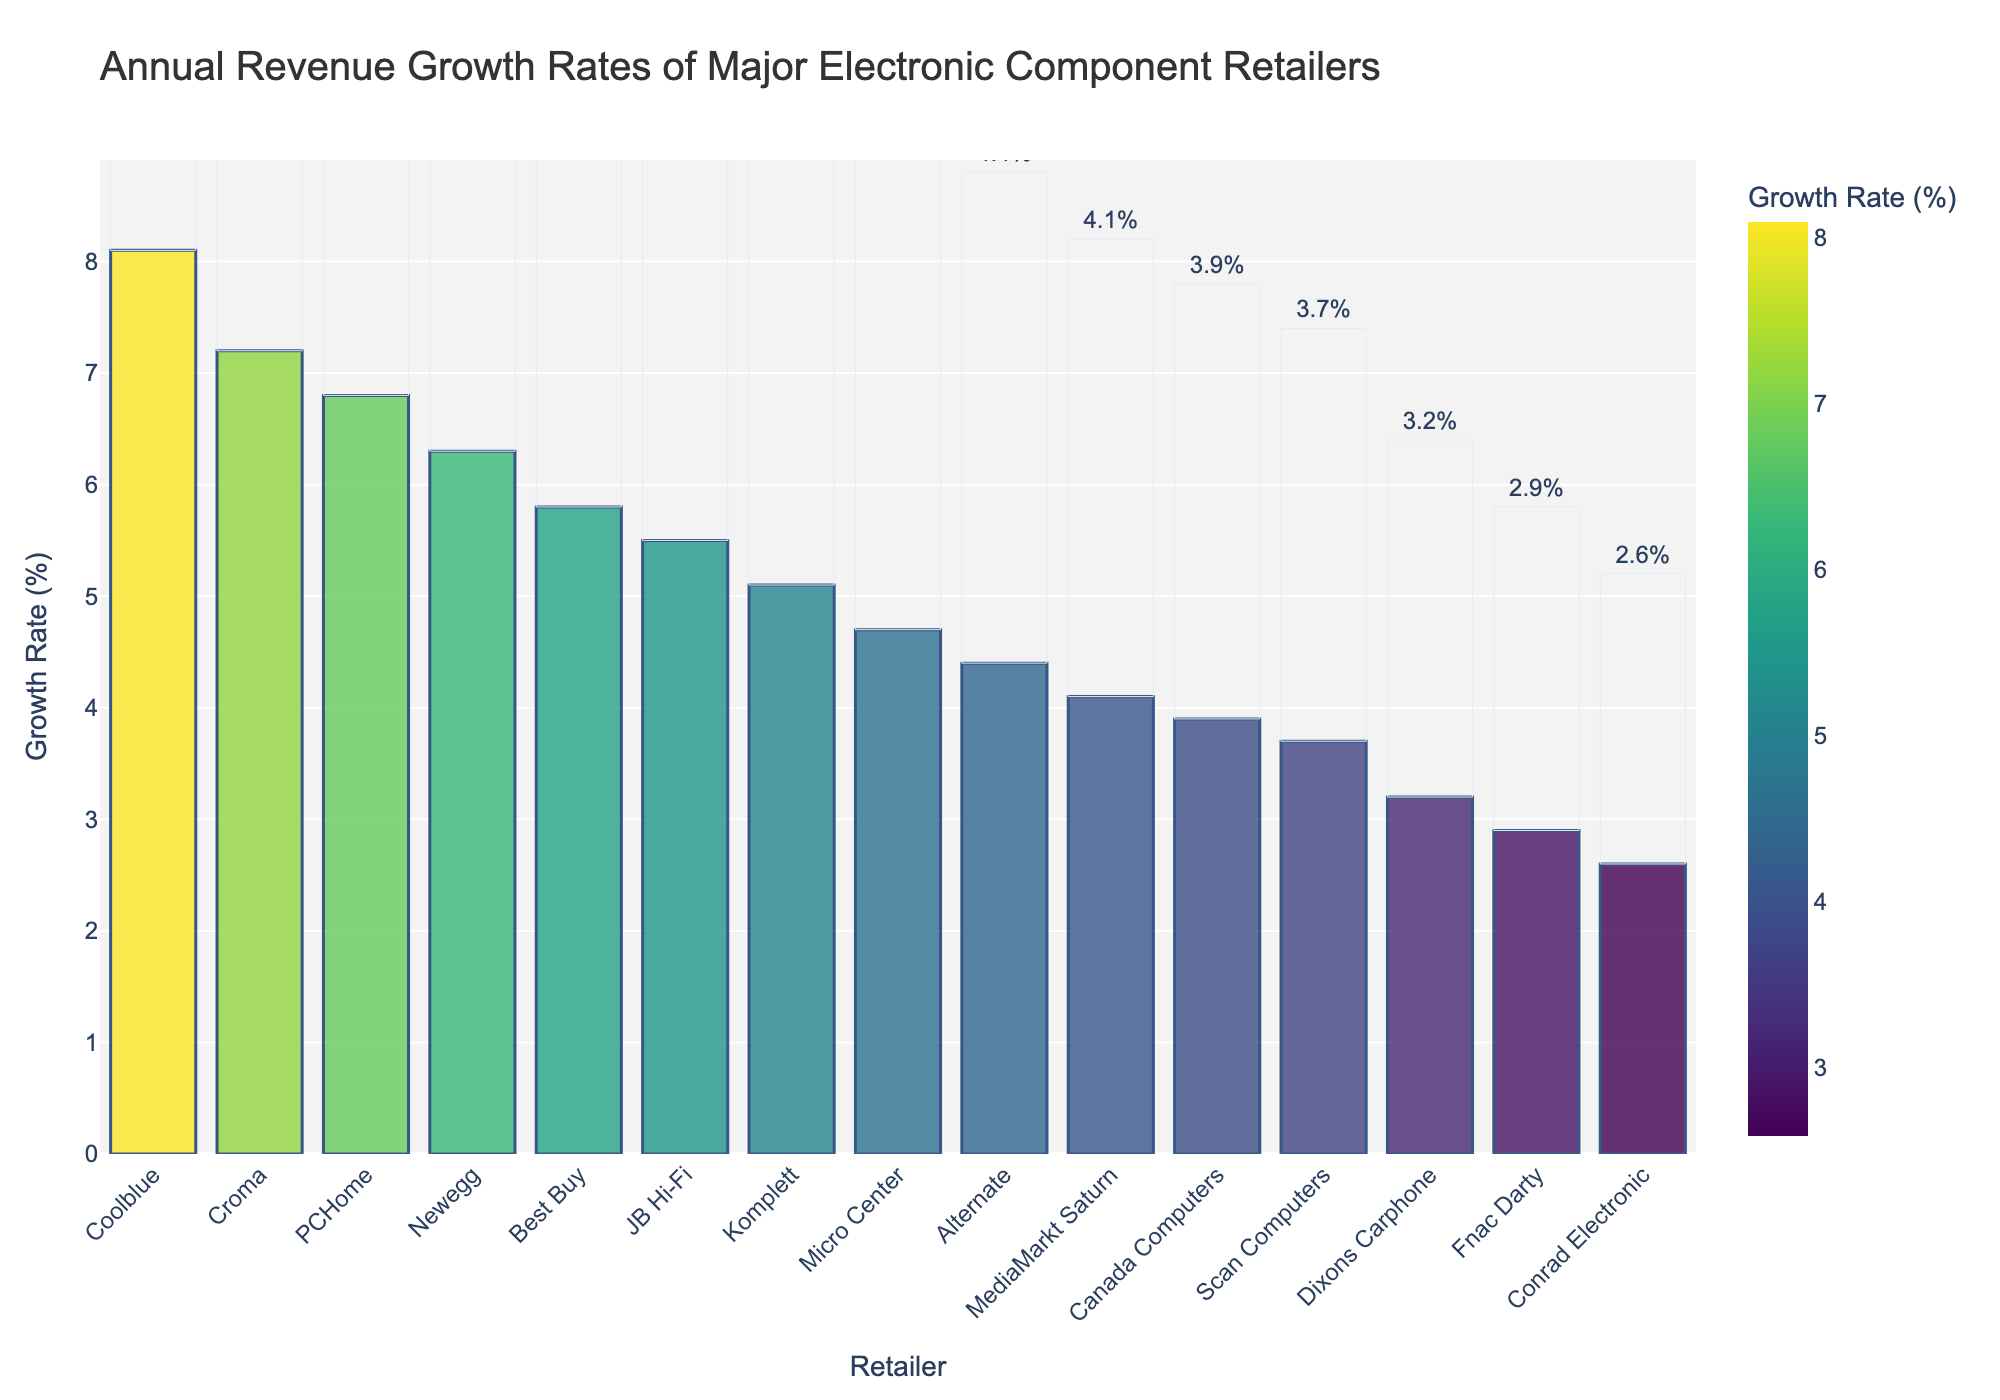Which retailer has the highest annual revenue growth rate? The bar chart shows the annual revenue growth rates of various retailers, and the tallest bar represents the retailer with the highest rate. Coolblue's bar is the tallest, indicating the highest growth rate.
Answer: Coolblue Which retailer has the lowest annual revenue growth rate, and what is its value? The shortest bar in the chart represents the retailer with the lowest growth rate. Conrad Electronic's bar is the shortest, indicating the lowest growth rate. The value is shown above the bar.
Answer: Conrad Electronic, 2.6% What is the difference in annual revenue growth rates between Coolblue and Conrad Electronic? Coolblue has the highest growth rate at 8.1%, and Conrad Electronic has the lowest at 2.6%. Subtract the latter from the former: 8.1% - 2.6% = 5.5%.
Answer: 5.5% How many retailers have an annual revenue growth rate higher than 5%? Count the bars that have growth rates higher than 5%. These are Coolblue, Croma, PCHome, Newegg, and Best Buy, which are 5 in total.
Answer: 5 What is the average annual revenue growth rate of retailers with a growth rate less than 4%? Identify the retailers with growth rates less than 4%, which are Conrad Electronic (2.6%), Fnac Darty (2.9%), Dixons Carphone (3.2%), and Scan Computers (3.7%). Calculate their average: (2.6 + 2.9 + 3.2 + 3.7) / 4 ≈ 3.1%.
Answer: 3.1% Compare the annual revenue growth rates of Newegg and JB Hi-Fi. Which retailer has a higher growth rate, and by how much? Newegg has a growth rate of 6.3%, while JB Hi-Fi has a rate of 5.5%. Subtract JB Hi-Fi's rate from Newegg's: 6.3% - 5.5% = 0.8%.
Answer: Newegg, by 0.8% What is the combined annual revenue growth rate of MediaMarkt Saturn, Micro Center, and Alternate? Add the growth rates of the three retailers: MediaMarkt Saturn (4.1%), Micro Center (4.7%), and Alternate (4.4%). 4.1% + 4.7% + 4.4% = 13.2%.
Answer: 13.2% Arrange Canada Computers, Komplett, and PCHome in ascending order of their annual revenue growth rates. Identify and list the growth rates: Canada Computers (3.9%), Komplett (5.1%), and PCHome (6.8%). Arrange them in ascending order: Canada Computers < Komplett < PCHome.
Answer: Canada Computers < Komplett < PCHome 